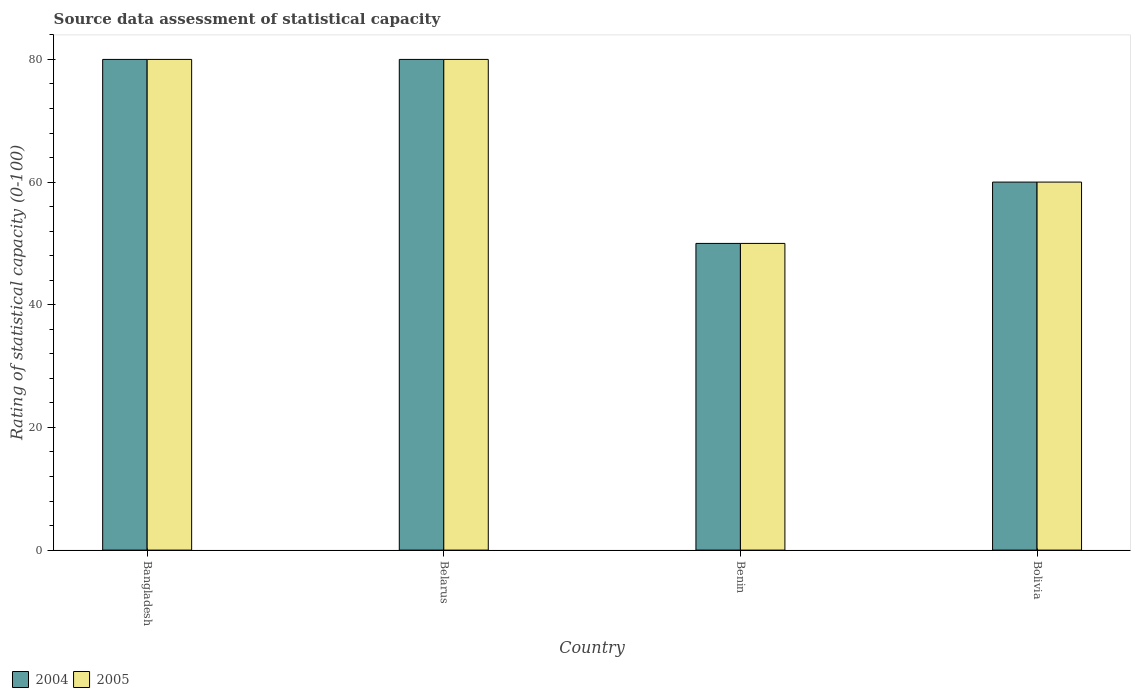How many different coloured bars are there?
Your response must be concise. 2. How many groups of bars are there?
Give a very brief answer. 4. Are the number of bars per tick equal to the number of legend labels?
Provide a succinct answer. Yes. Are the number of bars on each tick of the X-axis equal?
Make the answer very short. Yes. How many bars are there on the 1st tick from the left?
Keep it short and to the point. 2. How many bars are there on the 3rd tick from the right?
Offer a terse response. 2. What is the label of the 2nd group of bars from the left?
Keep it short and to the point. Belarus. In how many cases, is the number of bars for a given country not equal to the number of legend labels?
Your response must be concise. 0. Across all countries, what is the minimum rating of statistical capacity in 2004?
Offer a terse response. 50. In which country was the rating of statistical capacity in 2005 minimum?
Offer a very short reply. Benin. What is the total rating of statistical capacity in 2005 in the graph?
Keep it short and to the point. 270. What is the average rating of statistical capacity in 2005 per country?
Your answer should be very brief. 67.5. What is the ratio of the rating of statistical capacity in 2004 in Belarus to that in Bolivia?
Your answer should be very brief. 1.33. Is the rating of statistical capacity in 2004 in Bangladesh less than that in Belarus?
Your answer should be compact. No. Is the difference between the rating of statistical capacity in 2004 in Belarus and Benin greater than the difference between the rating of statistical capacity in 2005 in Belarus and Benin?
Your response must be concise. No. What is the difference between the highest and the second highest rating of statistical capacity in 2005?
Your response must be concise. 20. What is the difference between the highest and the lowest rating of statistical capacity in 2005?
Keep it short and to the point. 30. What does the 2nd bar from the right in Belarus represents?
Your answer should be compact. 2004. Are all the bars in the graph horizontal?
Offer a terse response. No. What is the difference between two consecutive major ticks on the Y-axis?
Offer a terse response. 20. Are the values on the major ticks of Y-axis written in scientific E-notation?
Offer a terse response. No. Does the graph contain grids?
Give a very brief answer. No. Where does the legend appear in the graph?
Offer a terse response. Bottom left. How many legend labels are there?
Provide a succinct answer. 2. How are the legend labels stacked?
Your answer should be compact. Horizontal. What is the title of the graph?
Make the answer very short. Source data assessment of statistical capacity. What is the label or title of the X-axis?
Make the answer very short. Country. What is the label or title of the Y-axis?
Offer a very short reply. Rating of statistical capacity (0-100). What is the Rating of statistical capacity (0-100) of 2004 in Bangladesh?
Provide a succinct answer. 80. What is the Rating of statistical capacity (0-100) in 2005 in Bangladesh?
Give a very brief answer. 80. What is the Rating of statistical capacity (0-100) of 2004 in Belarus?
Give a very brief answer. 80. What is the Rating of statistical capacity (0-100) in 2005 in Belarus?
Keep it short and to the point. 80. What is the Rating of statistical capacity (0-100) in 2004 in Benin?
Your response must be concise. 50. What is the Rating of statistical capacity (0-100) of 2005 in Bolivia?
Offer a very short reply. 60. Across all countries, what is the maximum Rating of statistical capacity (0-100) in 2004?
Ensure brevity in your answer.  80. Across all countries, what is the minimum Rating of statistical capacity (0-100) in 2004?
Offer a very short reply. 50. Across all countries, what is the minimum Rating of statistical capacity (0-100) in 2005?
Ensure brevity in your answer.  50. What is the total Rating of statistical capacity (0-100) of 2004 in the graph?
Ensure brevity in your answer.  270. What is the total Rating of statistical capacity (0-100) of 2005 in the graph?
Your answer should be very brief. 270. What is the difference between the Rating of statistical capacity (0-100) of 2005 in Bangladesh and that in Belarus?
Your answer should be compact. 0. What is the difference between the Rating of statistical capacity (0-100) of 2004 in Bangladesh and that in Benin?
Give a very brief answer. 30. What is the difference between the Rating of statistical capacity (0-100) of 2005 in Bangladesh and that in Benin?
Offer a very short reply. 30. What is the difference between the Rating of statistical capacity (0-100) in 2005 in Bangladesh and that in Bolivia?
Offer a terse response. 20. What is the difference between the Rating of statistical capacity (0-100) of 2005 in Belarus and that in Benin?
Give a very brief answer. 30. What is the difference between the Rating of statistical capacity (0-100) of 2004 in Belarus and that in Bolivia?
Provide a succinct answer. 20. What is the difference between the Rating of statistical capacity (0-100) in 2005 in Benin and that in Bolivia?
Ensure brevity in your answer.  -10. What is the difference between the Rating of statistical capacity (0-100) in 2004 in Bangladesh and the Rating of statistical capacity (0-100) in 2005 in Belarus?
Your response must be concise. 0. What is the difference between the Rating of statistical capacity (0-100) of 2004 in Bangladesh and the Rating of statistical capacity (0-100) of 2005 in Bolivia?
Provide a short and direct response. 20. What is the difference between the Rating of statistical capacity (0-100) of 2004 in Belarus and the Rating of statistical capacity (0-100) of 2005 in Bolivia?
Keep it short and to the point. 20. What is the difference between the Rating of statistical capacity (0-100) of 2004 in Benin and the Rating of statistical capacity (0-100) of 2005 in Bolivia?
Give a very brief answer. -10. What is the average Rating of statistical capacity (0-100) in 2004 per country?
Provide a short and direct response. 67.5. What is the average Rating of statistical capacity (0-100) of 2005 per country?
Provide a short and direct response. 67.5. What is the difference between the Rating of statistical capacity (0-100) in 2004 and Rating of statistical capacity (0-100) in 2005 in Bangladesh?
Give a very brief answer. 0. What is the difference between the Rating of statistical capacity (0-100) of 2004 and Rating of statistical capacity (0-100) of 2005 in Benin?
Your answer should be very brief. 0. What is the difference between the Rating of statistical capacity (0-100) of 2004 and Rating of statistical capacity (0-100) of 2005 in Bolivia?
Your answer should be compact. 0. What is the ratio of the Rating of statistical capacity (0-100) in 2004 in Bangladesh to that in Belarus?
Provide a succinct answer. 1. What is the ratio of the Rating of statistical capacity (0-100) of 2004 in Bangladesh to that in Bolivia?
Offer a very short reply. 1.33. What is the ratio of the Rating of statistical capacity (0-100) in 2005 in Bangladesh to that in Bolivia?
Provide a short and direct response. 1.33. What is the ratio of the Rating of statistical capacity (0-100) of 2004 in Belarus to that in Bolivia?
Offer a very short reply. 1.33. What is the ratio of the Rating of statistical capacity (0-100) in 2004 in Benin to that in Bolivia?
Make the answer very short. 0.83. What is the difference between the highest and the second highest Rating of statistical capacity (0-100) in 2004?
Give a very brief answer. 0. What is the difference between the highest and the second highest Rating of statistical capacity (0-100) of 2005?
Your answer should be compact. 0. What is the difference between the highest and the lowest Rating of statistical capacity (0-100) in 2005?
Give a very brief answer. 30. 